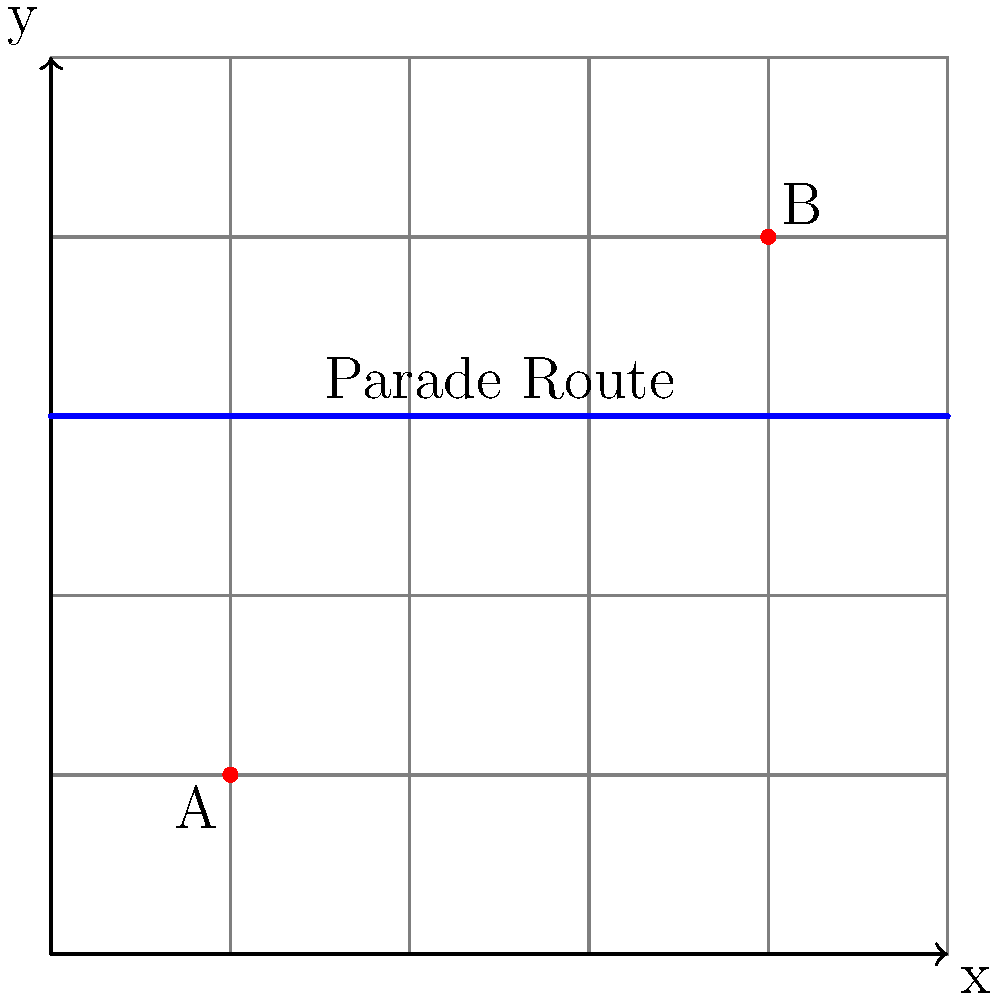As a busy executive, you need to attend a meeting at Office B from your current location at Office A. However, there's a citywide parade blocking the direct route. Given that each grid unit represents 100 meters, and you must walk around the parade route, what is the shortest distance you need to travel? Round your answer to the nearest meter. Let's approach this step-by-step:

1) First, we need to identify the coordinates of both offices:
   Office A: (2, 2)
   Office B: (8, 8)

2) The parade route is at y = 6, so we need to go around it.

3) The shortest path will involve:
   - Moving from A (2, 2) to point (2, 6)
   - Moving along the parade route to point (8, 6)
   - Moving from (8, 6) to B (8, 8)

4) Let's calculate each segment:
   - From (2, 2) to (2, 6): 
     Vertical distance = 6 - 2 = 4 units
   - From (2, 6) to (8, 6):
     Horizontal distance = 8 - 2 = 6 units
   - From (8, 6) to (8, 8):
     Vertical distance = 8 - 6 = 2 units

5) Total distance in grid units:
   4 + 6 + 2 = 12 units

6) Convert to meters:
   12 * 100 = 1200 meters

Therefore, the shortest distance you need to travel is 1200 meters.
Answer: 1200 meters 